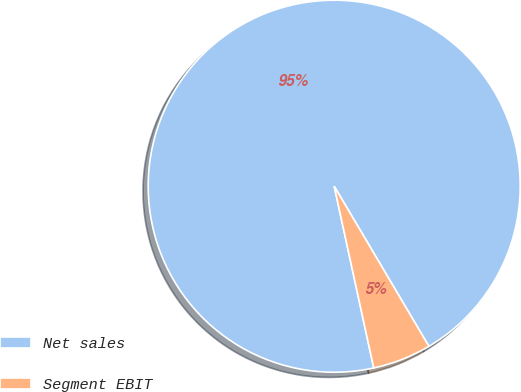Convert chart. <chart><loc_0><loc_0><loc_500><loc_500><pie_chart><fcel>Net sales<fcel>Segment EBIT<nl><fcel>94.91%<fcel>5.09%<nl></chart> 